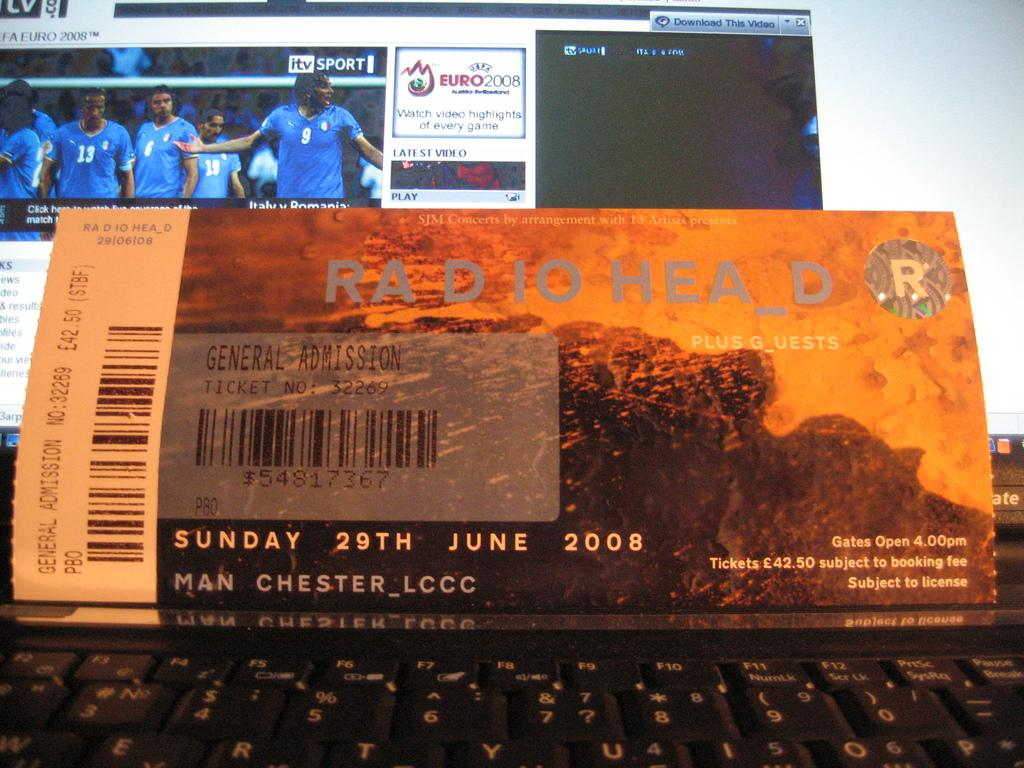Provide a one-sentence caption for the provided image. Ticket for Radio Head resting on top of a black keyboard. 